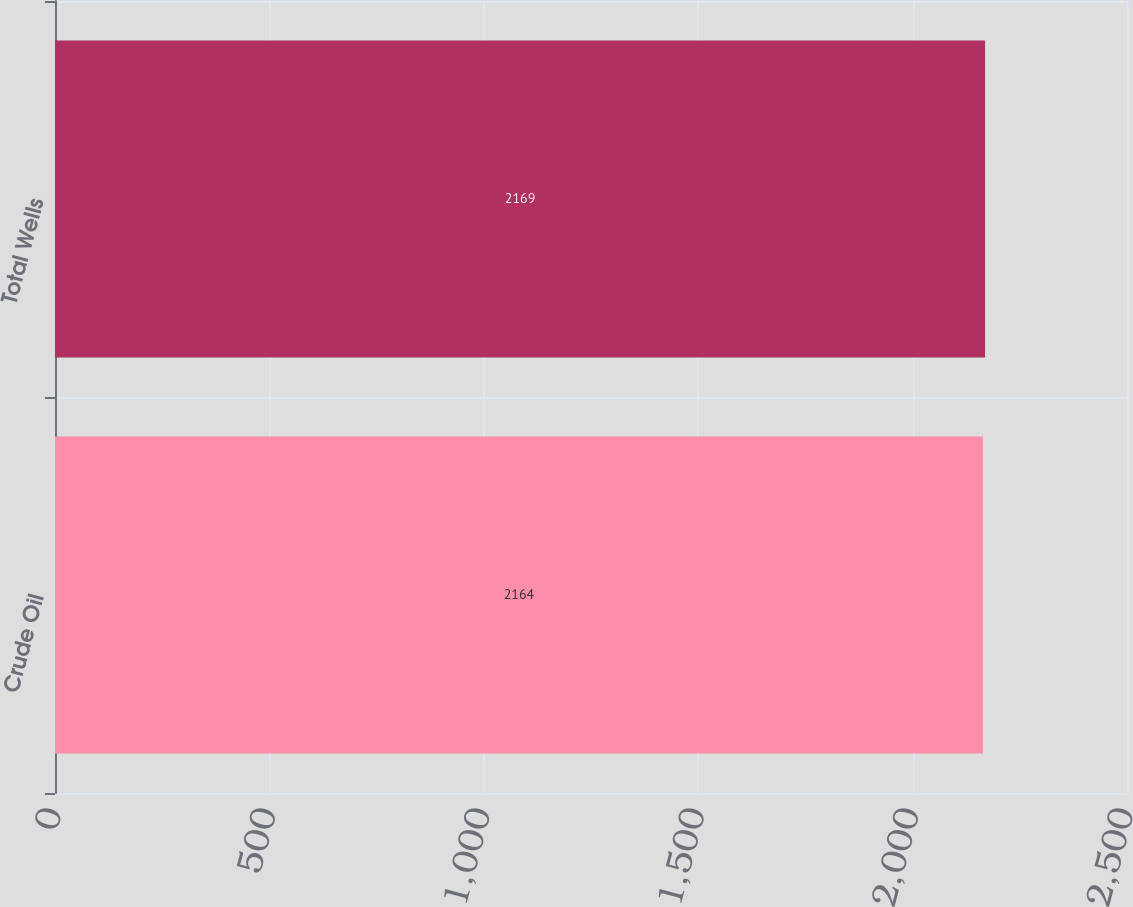Convert chart to OTSL. <chart><loc_0><loc_0><loc_500><loc_500><bar_chart><fcel>Crude Oil<fcel>Total Wells<nl><fcel>2164<fcel>2169<nl></chart> 